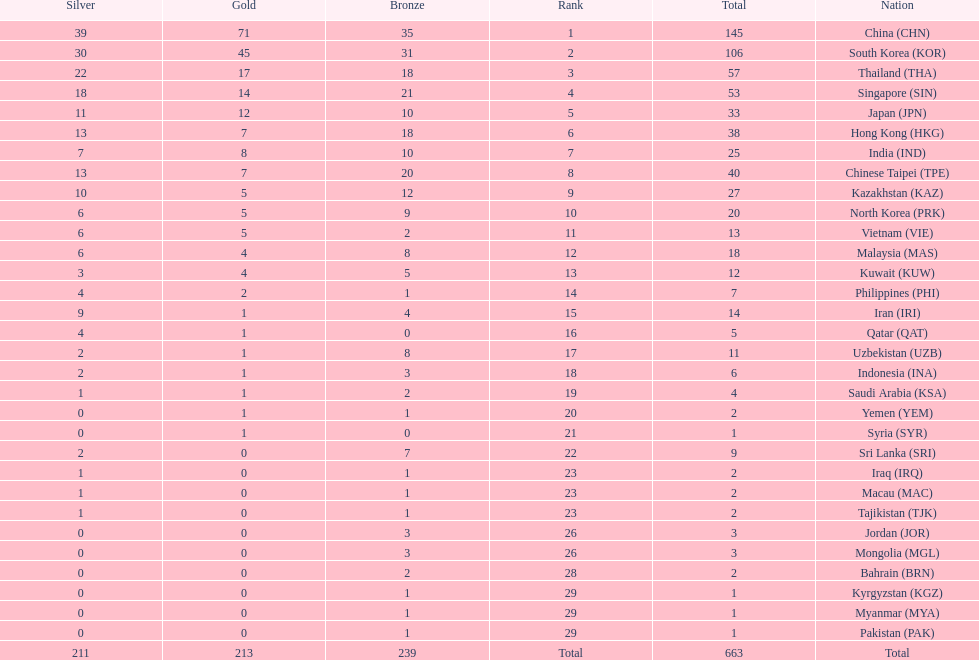What is the cumulative count of medals india achieved in the asian youth games? 25. 